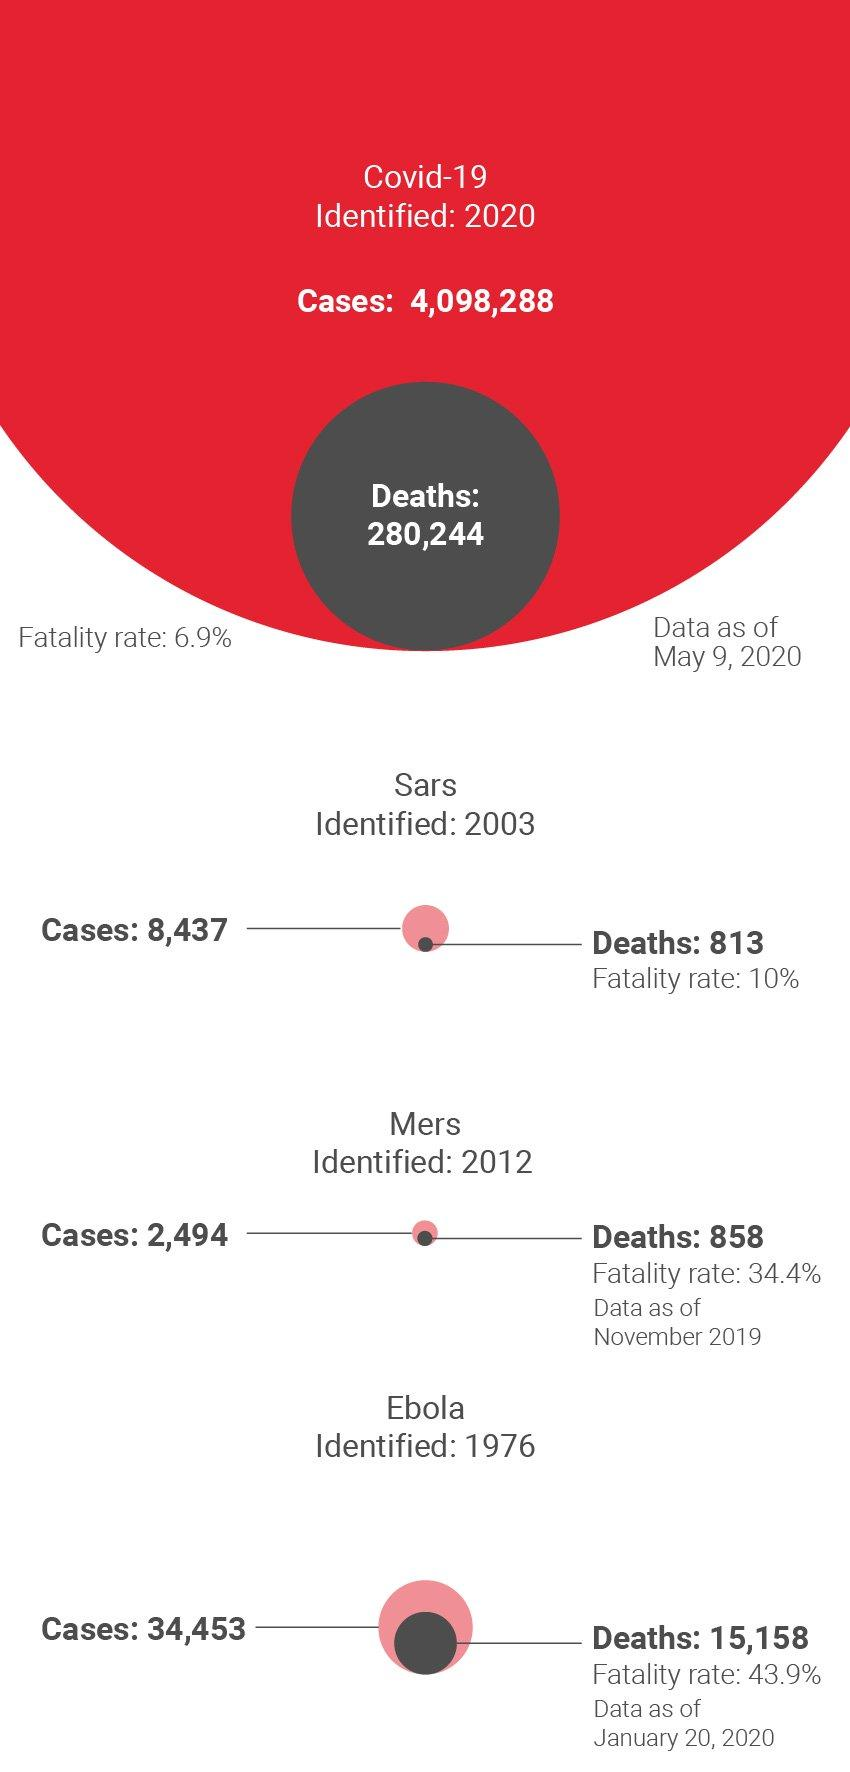Mention a couple of crucial points in this snapshot. The fatality rate of Covid-19 is 6.9%. The fatality rate of SARS is estimated to be approximately 10%. The disease with a fatality rate of 34.4% is Mers. The disease that was identified in the early 2000s is SARS. SARS is associated with the lowest number of reported deaths among the listed diseases. 